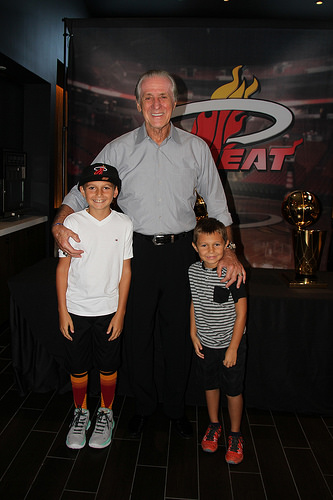<image>
Can you confirm if the shirt is on the man? No. The shirt is not positioned on the man. They may be near each other, but the shirt is not supported by or resting on top of the man. Is the boy to the right of the window? Yes. From this viewpoint, the boy is positioned to the right side relative to the window. 